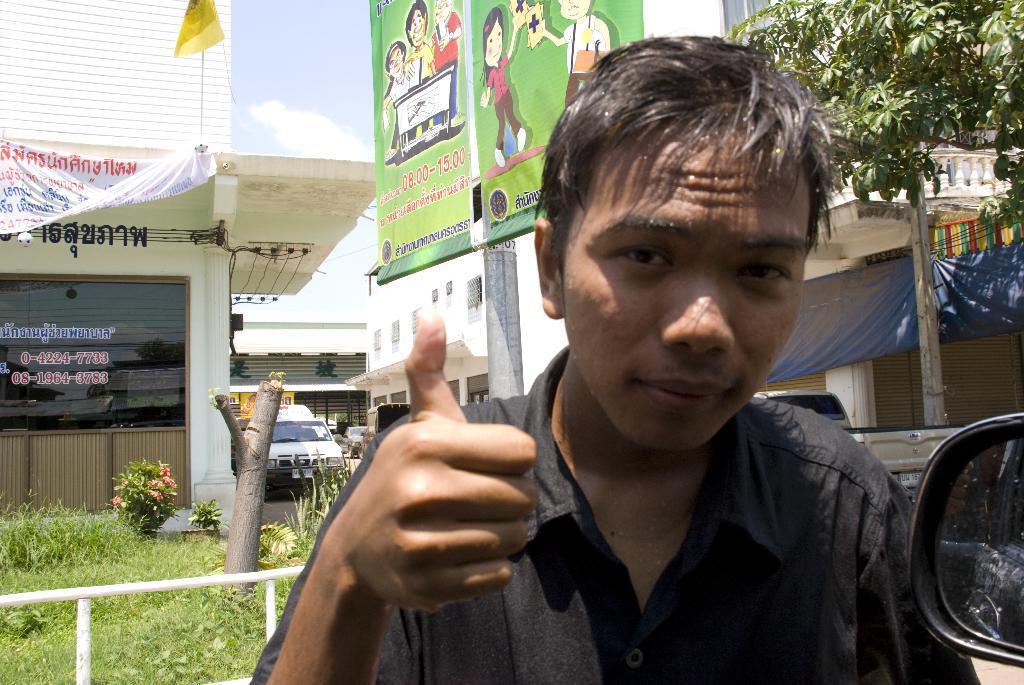Could you give a brief overview of what you see in this image? In this image I can see a person wearing black color dress is stunning. In the background I can see the railing, few plants, few trees, few buildings, few banners, a yellow colored flag, a vehicle and the sky in the background. 